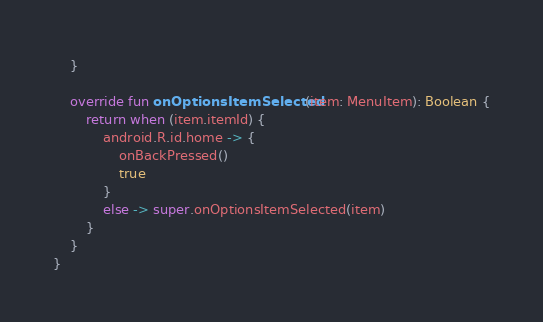Convert code to text. <code><loc_0><loc_0><loc_500><loc_500><_Kotlin_>    }

    override fun onOptionsItemSelected(item: MenuItem): Boolean {
        return when (item.itemId) {
            android.R.id.home -> {
                onBackPressed()
                true
            }
            else -> super.onOptionsItemSelected(item)
        }
    }
}
</code> 